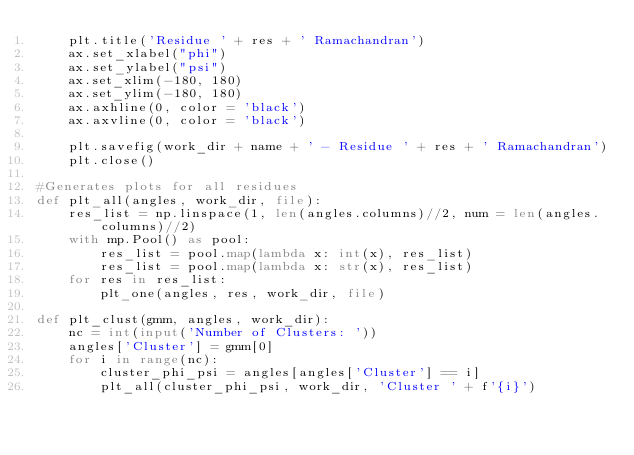<code> <loc_0><loc_0><loc_500><loc_500><_Python_>    plt.title('Residue ' + res + ' Ramachandran')
    ax.set_xlabel("phi")
    ax.set_ylabel("psi")
    ax.set_xlim(-180, 180)
    ax.set_ylim(-180, 180)
    ax.axhline(0, color = 'black')
    ax.axvline(0, color = 'black')
    
    plt.savefig(work_dir + name + ' - Residue ' + res + ' Ramachandran')
    plt.close()

#Generates plots for all residues
def plt_all(angles, work_dir, file):    
    res_list = np.linspace(1, len(angles.columns)//2, num = len(angles.columns)//2)
    with mp.Pool() as pool:
        res_list = pool.map(lambda x: int(x), res_list)
        res_list = pool.map(lambda x: str(x), res_list)
    for res in res_list:
        plt_one(angles, res, work_dir, file)
        
def plt_clust(gmm, angles, work_dir):
    nc = int(input('Number of Clusters: '))
    angles['Cluster'] = gmm[0]
    for i in range(nc):
        cluster_phi_psi = angles[angles['Cluster'] == i]
        plt_all(cluster_phi_psi, work_dir, 'Cluster ' + f'{i}')</code> 